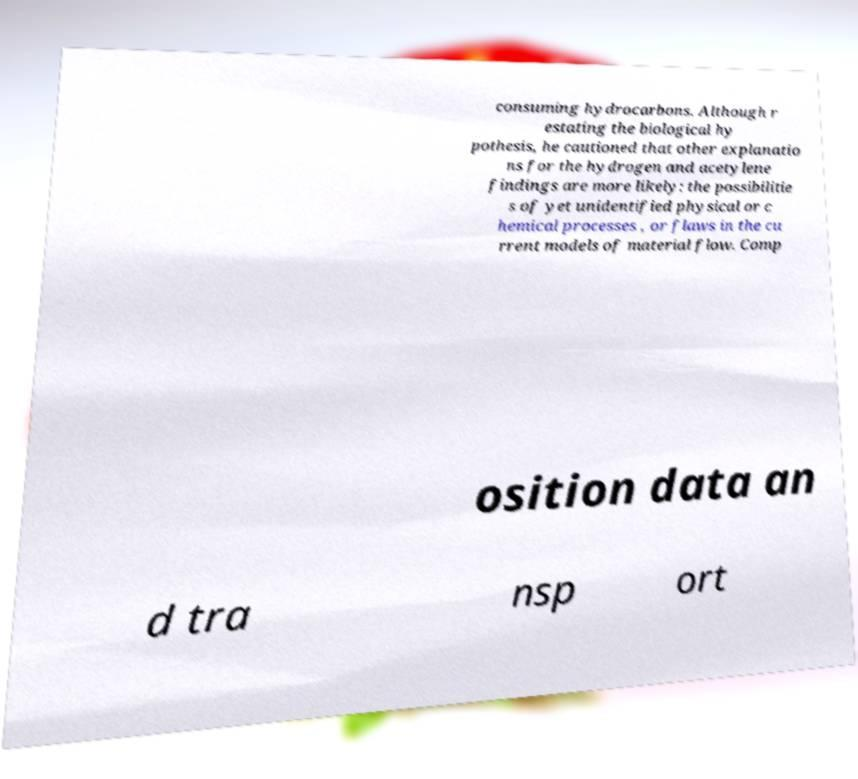Can you read and provide the text displayed in the image?This photo seems to have some interesting text. Can you extract and type it out for me? consuming hydrocarbons. Although r estating the biological hy pothesis, he cautioned that other explanatio ns for the hydrogen and acetylene findings are more likely: the possibilitie s of yet unidentified physical or c hemical processes , or flaws in the cu rrent models of material flow. Comp osition data an d tra nsp ort 